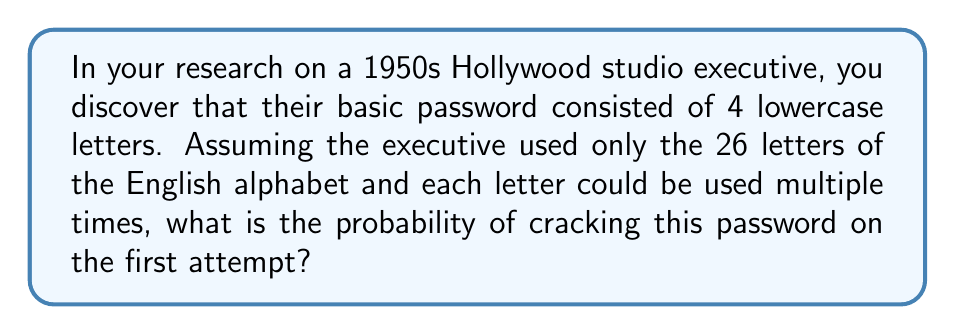Can you solve this math problem? To solve this problem, we need to follow these steps:

1. Determine the total number of possible passwords:
   - There are 26 choices for each of the 4 positions in the password
   - The total number of possibilities is therefore $26^4$

2. Calculate the probability of guessing the correct password on the first attempt:
   - The probability is 1 divided by the total number of possibilities
   - Probability = $\frac{1}{26^4}$

3. Simplify the fraction:
   $$\frac{1}{26^4} = \frac{1}{456976}$$

Therefore, the probability of cracking the studio executive's password on the first attempt is $\frac{1}{456976}$ or approximately $2.19 \times 10^{-6}$.
Answer: $\frac{1}{456976}$ 